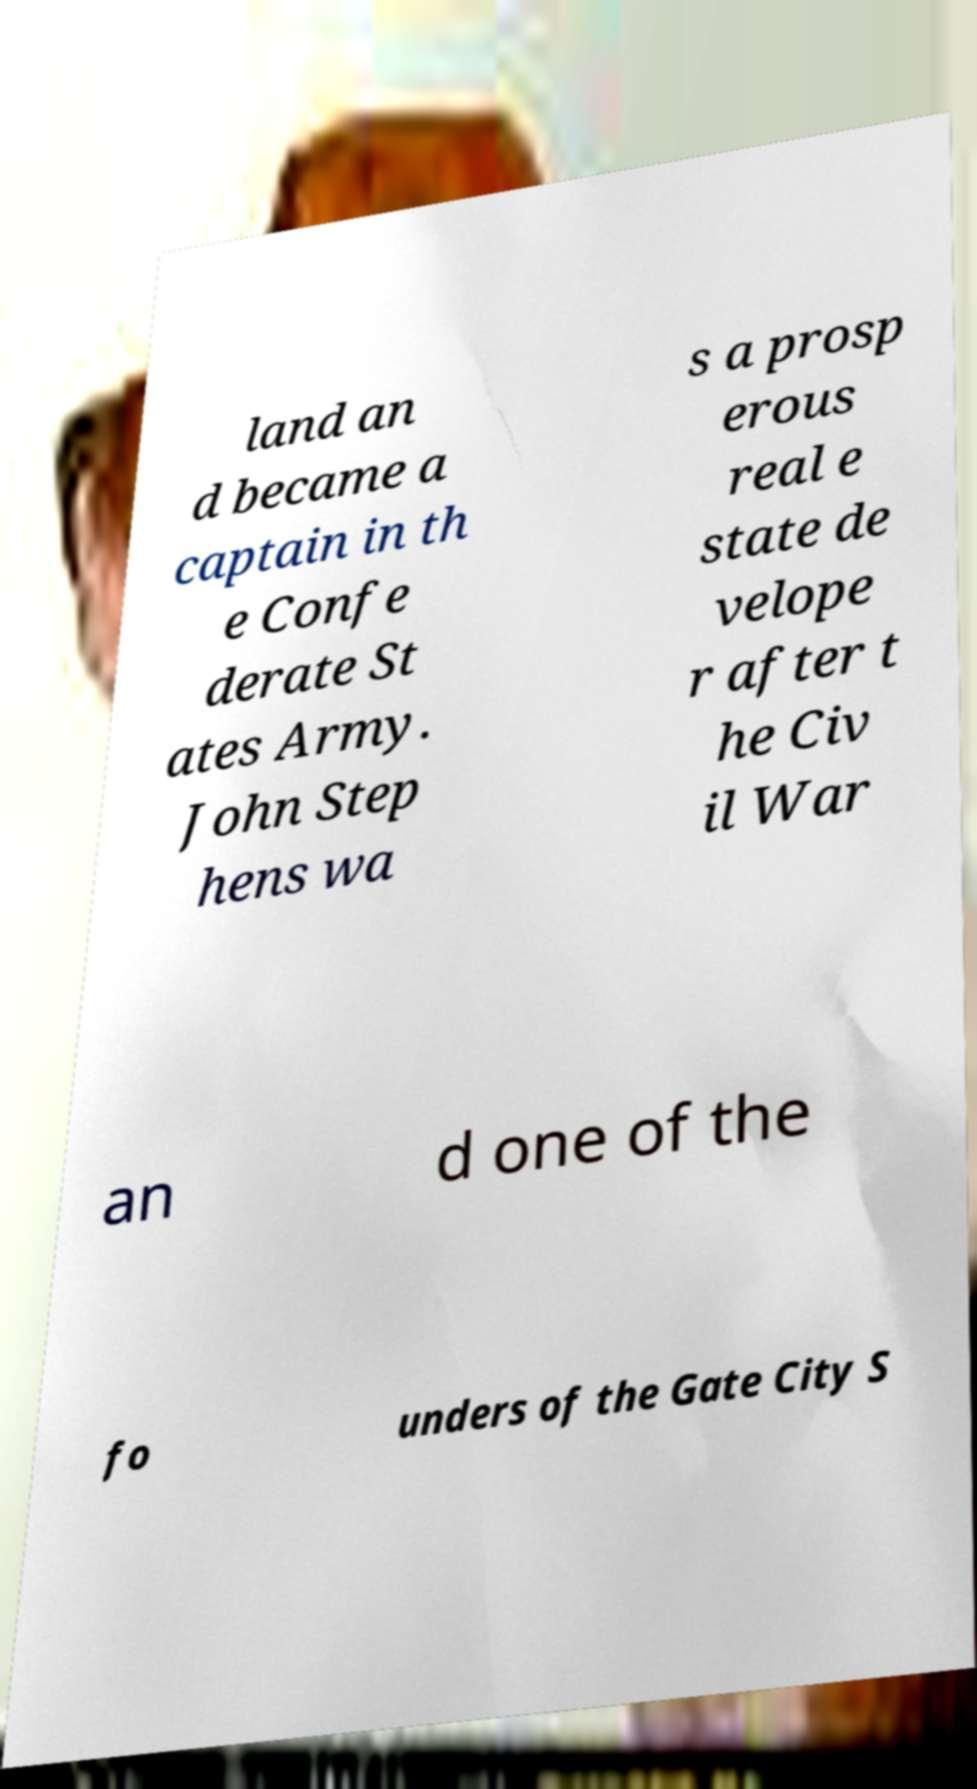What messages or text are displayed in this image? I need them in a readable, typed format. land an d became a captain in th e Confe derate St ates Army. John Step hens wa s a prosp erous real e state de velope r after t he Civ il War an d one of the fo unders of the Gate City S 